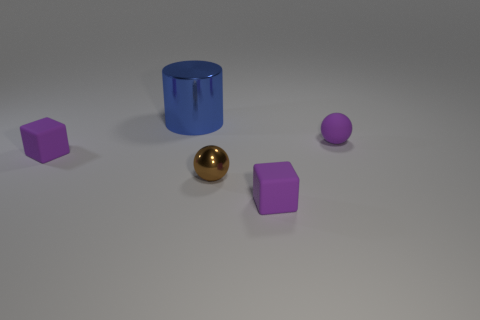Add 3 small cyan objects. How many objects exist? 8 Subtract all spheres. How many objects are left? 3 Add 3 metal cylinders. How many metal cylinders exist? 4 Subtract 1 blue cylinders. How many objects are left? 4 Subtract all small metal things. Subtract all big metal things. How many objects are left? 3 Add 4 tiny purple matte spheres. How many tiny purple matte spheres are left? 5 